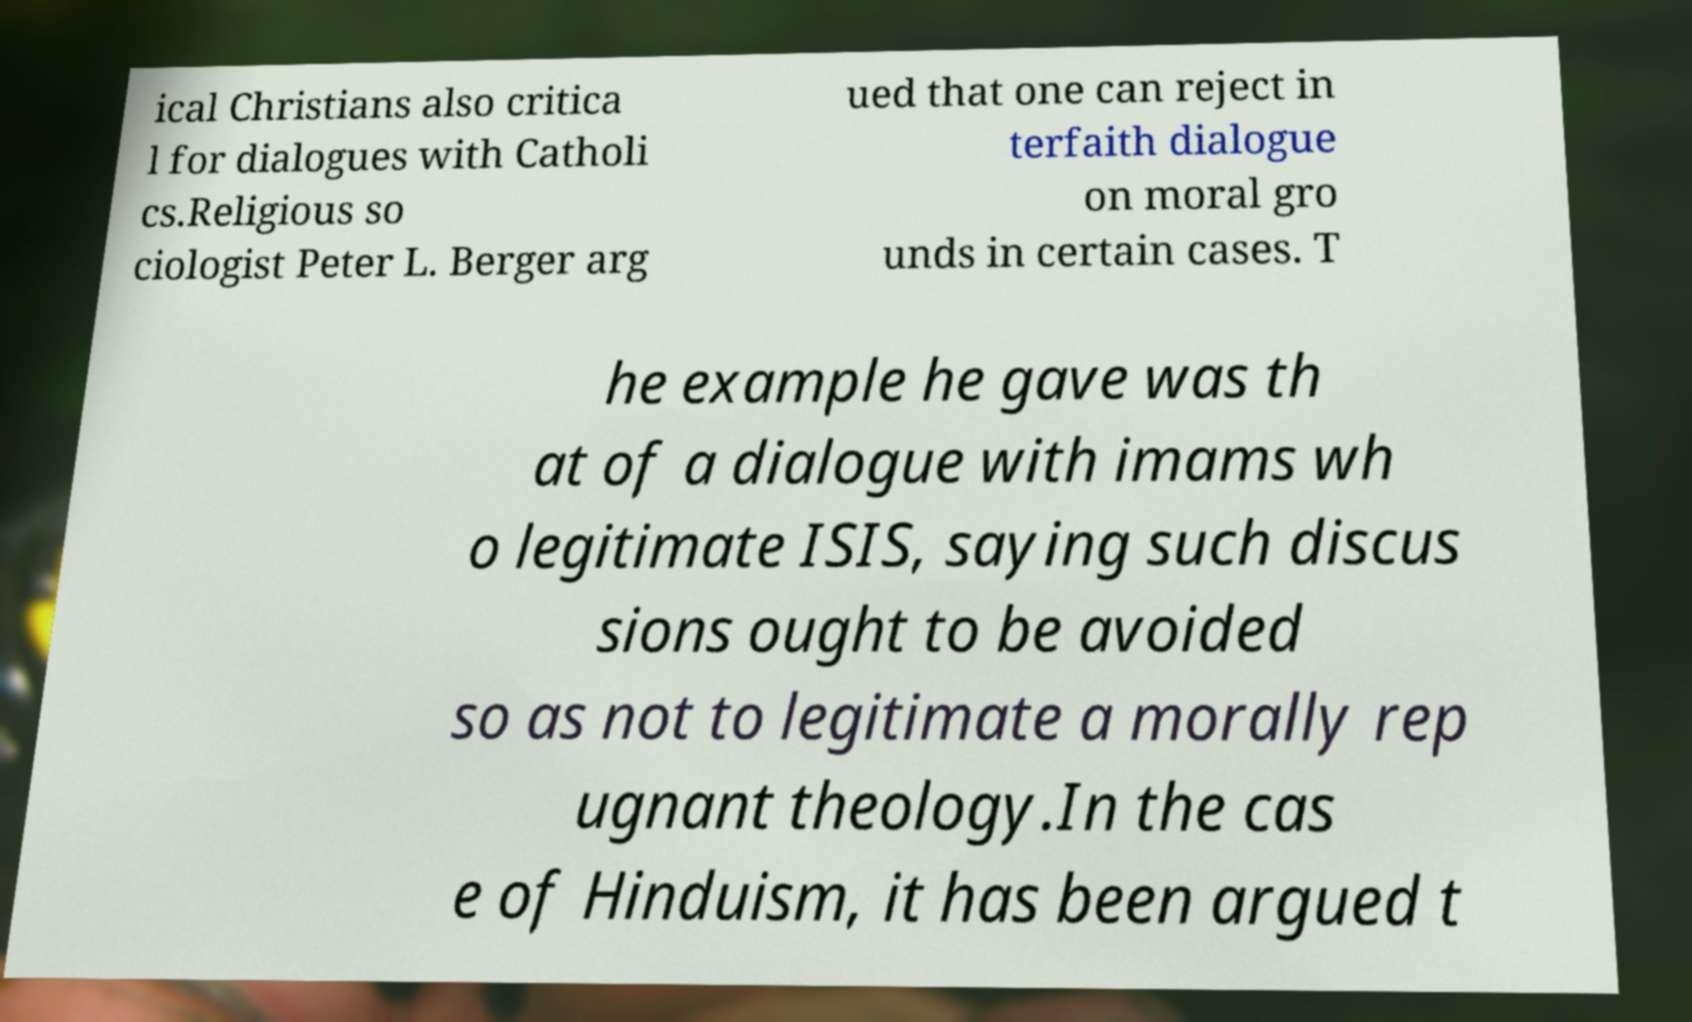Can you read and provide the text displayed in the image?This photo seems to have some interesting text. Can you extract and type it out for me? ical Christians also critica l for dialogues with Catholi cs.Religious so ciologist Peter L. Berger arg ued that one can reject in terfaith dialogue on moral gro unds in certain cases. T he example he gave was th at of a dialogue with imams wh o legitimate ISIS, saying such discus sions ought to be avoided so as not to legitimate a morally rep ugnant theology.In the cas e of Hinduism, it has been argued t 